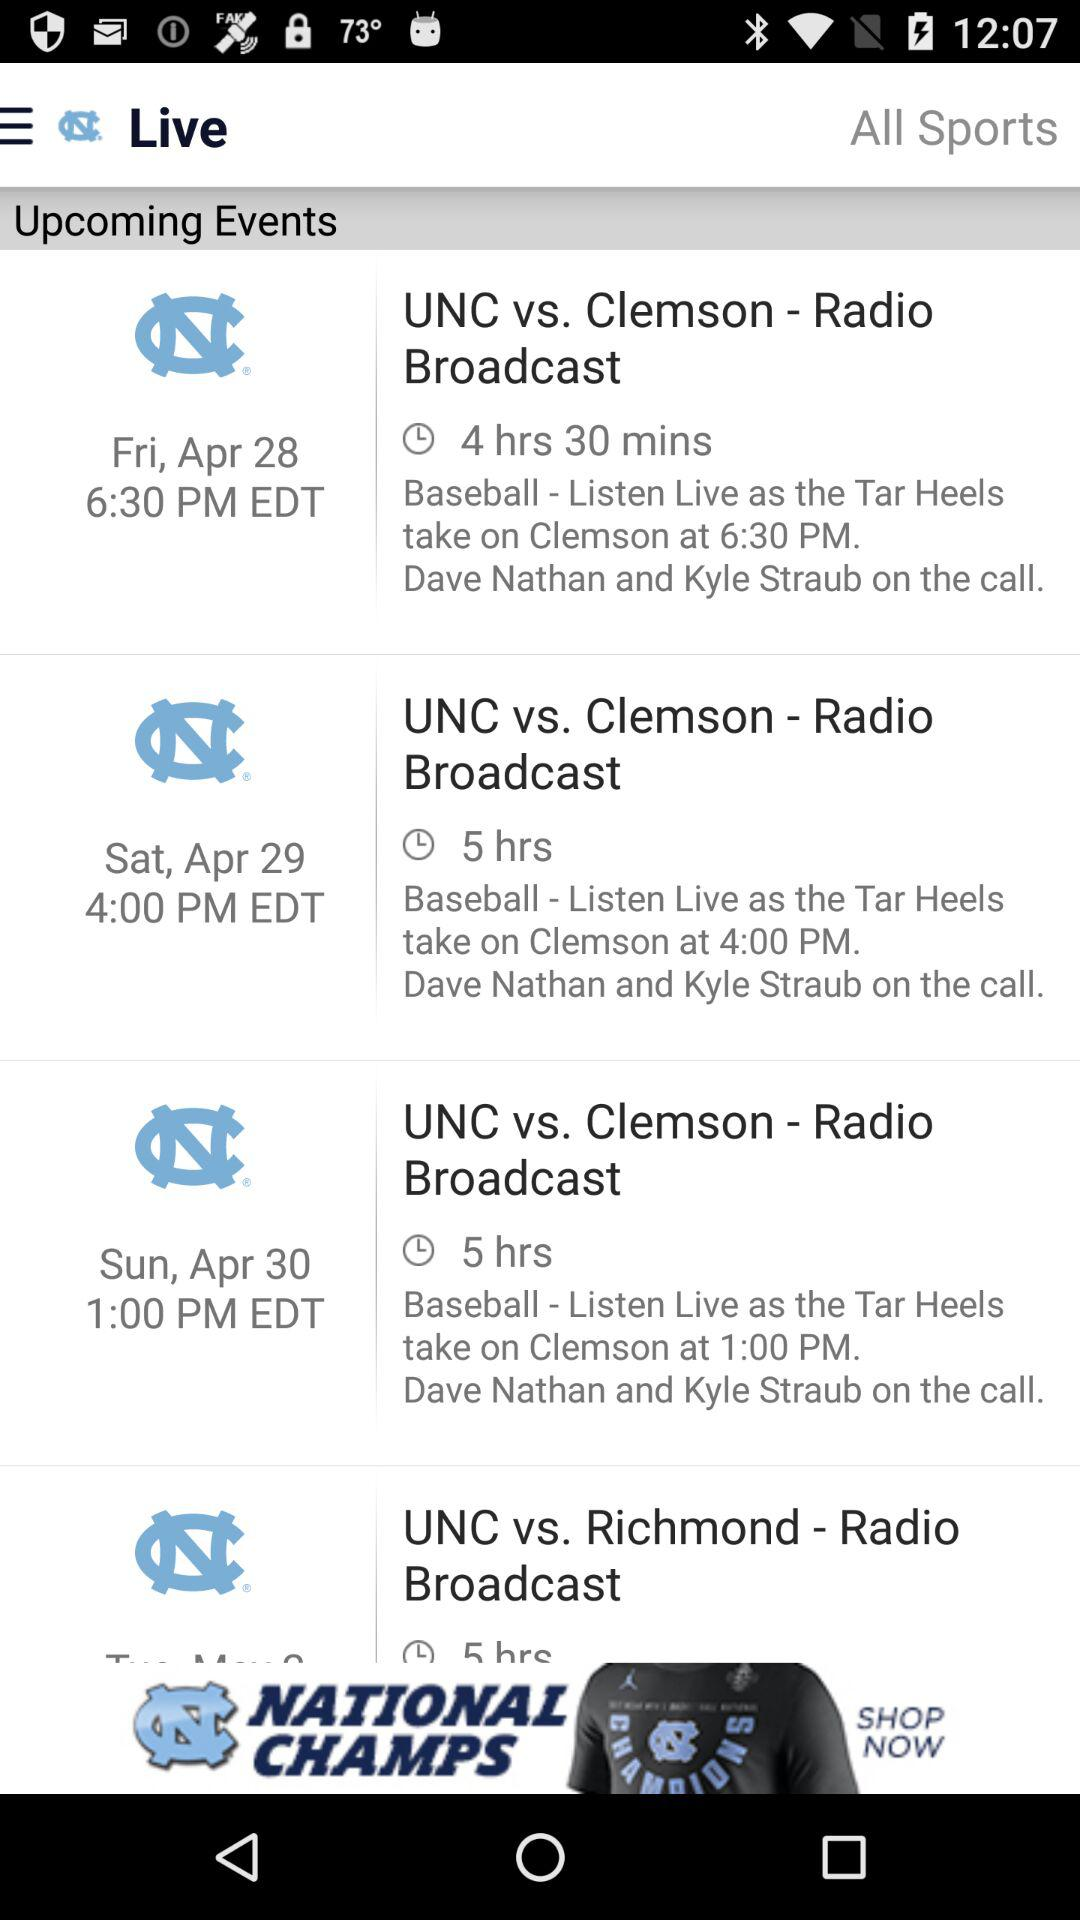Which event was posted 6 hours ago?
When the provided information is insufficient, respond with <no answer>. <no answer> 